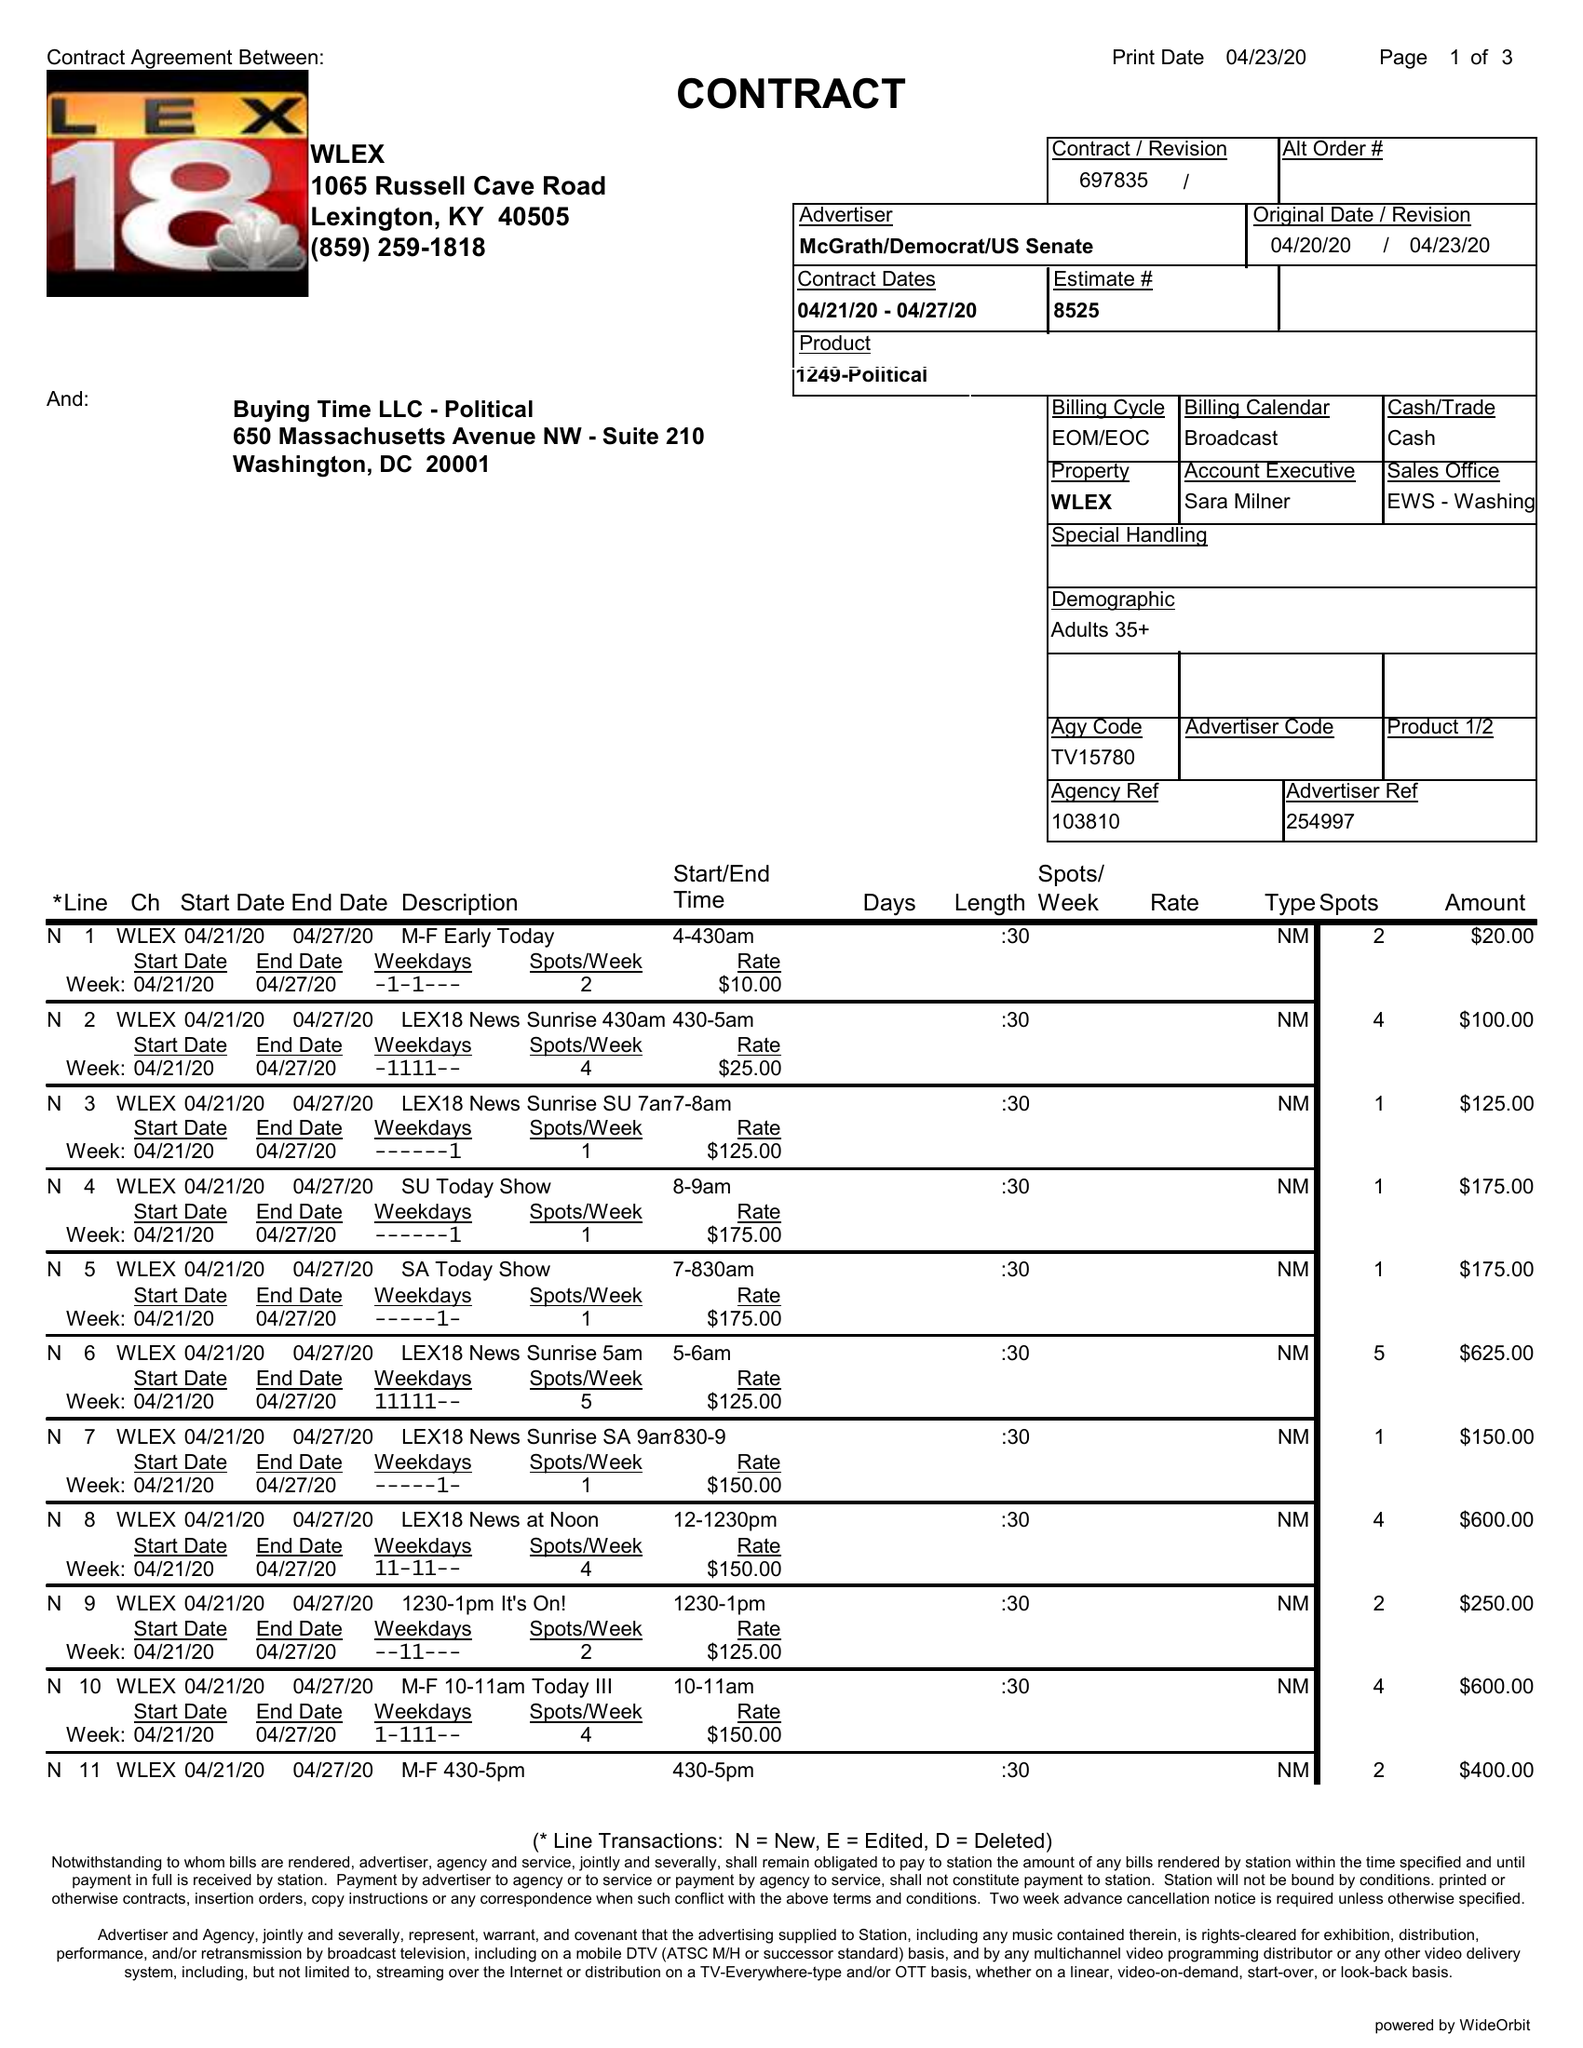What is the value for the advertiser?
Answer the question using a single word or phrase. MCGRATH/DEMOCRAT/USSENATE 